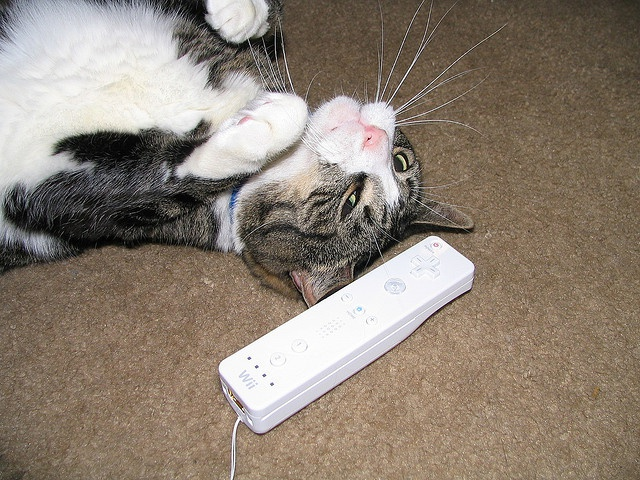Describe the objects in this image and their specific colors. I can see cat in black, lightgray, gray, and darkgray tones and remote in black, white, darkgray, and gray tones in this image. 